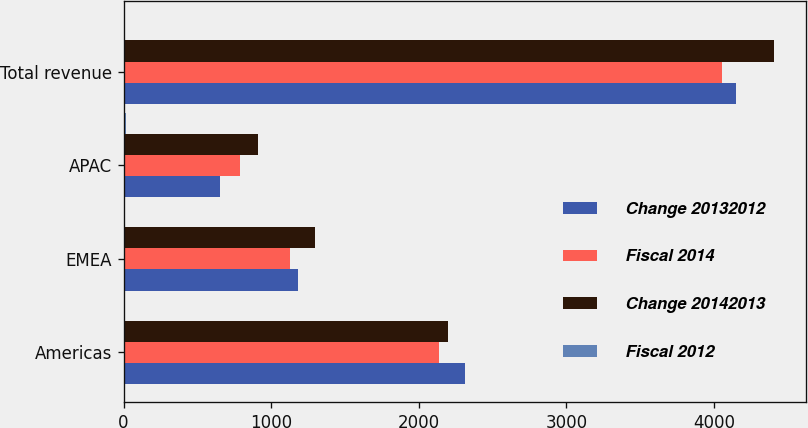<chart> <loc_0><loc_0><loc_500><loc_500><stacked_bar_chart><ecel><fcel>Americas<fcel>EMEA<fcel>APAC<fcel>Total revenue<nl><fcel>Change 20132012<fcel>2314.4<fcel>1179.9<fcel>652.8<fcel>4147.1<nl><fcel>Fiscal 2014<fcel>2134.4<fcel>1129.2<fcel>791.6<fcel>4055.2<nl><fcel>Change 20142013<fcel>2196.4<fcel>1294.6<fcel>912.7<fcel>4403.7<nl><fcel>Fiscal 2012<fcel>8<fcel>4<fcel>18<fcel>2<nl></chart> 